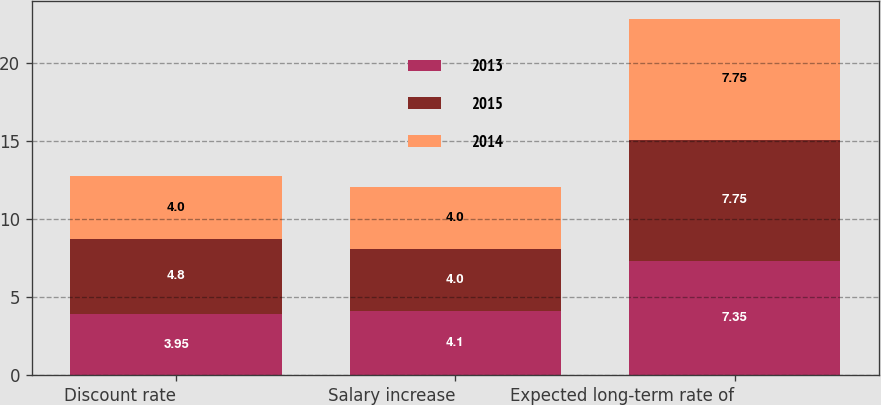Convert chart. <chart><loc_0><loc_0><loc_500><loc_500><stacked_bar_chart><ecel><fcel>Discount rate<fcel>Salary increase<fcel>Expected long-term rate of<nl><fcel>2013<fcel>3.95<fcel>4.1<fcel>7.35<nl><fcel>2015<fcel>4.8<fcel>4<fcel>7.75<nl><fcel>2014<fcel>4<fcel>4<fcel>7.75<nl></chart> 